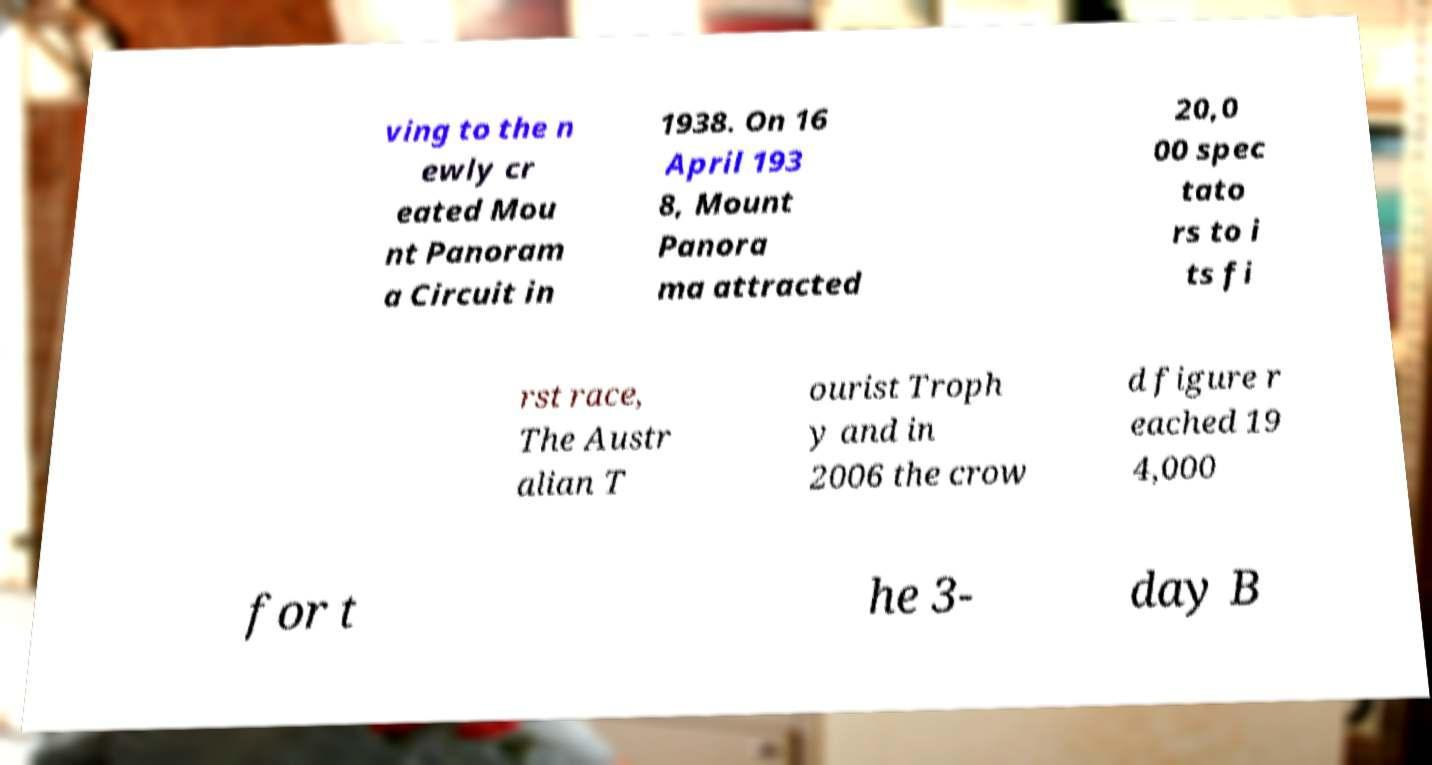Please read and relay the text visible in this image. What does it say? ving to the n ewly cr eated Mou nt Panoram a Circuit in 1938. On 16 April 193 8, Mount Panora ma attracted 20,0 00 spec tato rs to i ts fi rst race, The Austr alian T ourist Troph y and in 2006 the crow d figure r eached 19 4,000 for t he 3- day B 